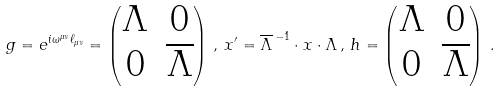Convert formula to latex. <formula><loc_0><loc_0><loc_500><loc_500>g = e ^ { i \omega ^ { \mu \nu } \ell _ { \mu \nu } } = \begin{pmatrix} \Lambda & 0 \\ 0 & \overline { \Lambda } \end{pmatrix} \, , \, x ^ { \prime } = \overline { \Lambda } ^ { \, - 1 } \cdot x \cdot \Lambda \, , \, h = \begin{pmatrix} \Lambda & 0 \\ 0 & \overline { \Lambda } \end{pmatrix} \, .</formula> 